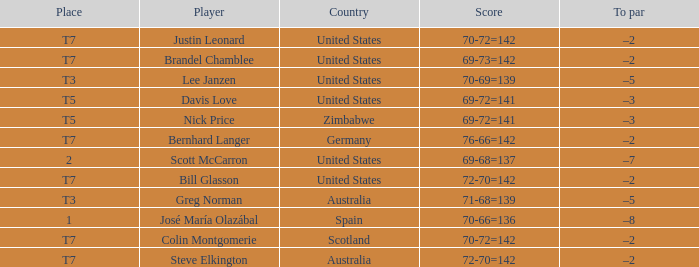Name the Player who has a Country of united states, and a To par of –5? Lee Janzen. 